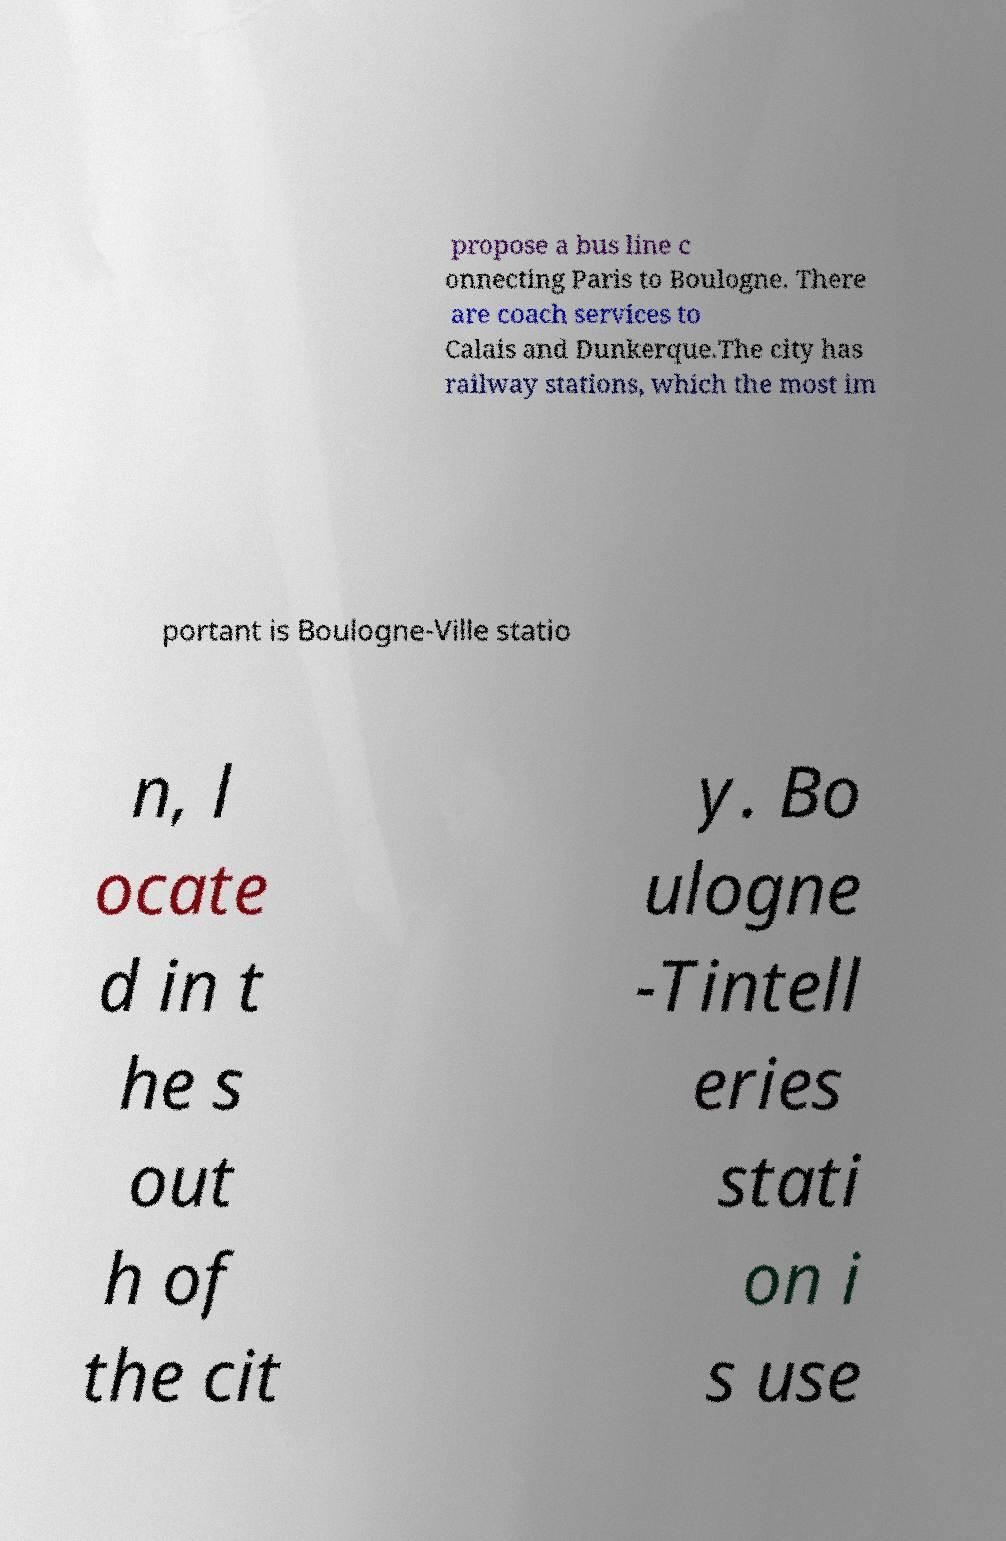What messages or text are displayed in this image? I need them in a readable, typed format. propose a bus line c onnecting Paris to Boulogne. There are coach services to Calais and Dunkerque.The city has railway stations, which the most im portant is Boulogne-Ville statio n, l ocate d in t he s out h of the cit y. Bo ulogne -Tintell eries stati on i s use 